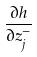Convert formula to latex. <formula><loc_0><loc_0><loc_500><loc_500>\frac { \partial h } { \partial z _ { j } ^ { - } }</formula> 